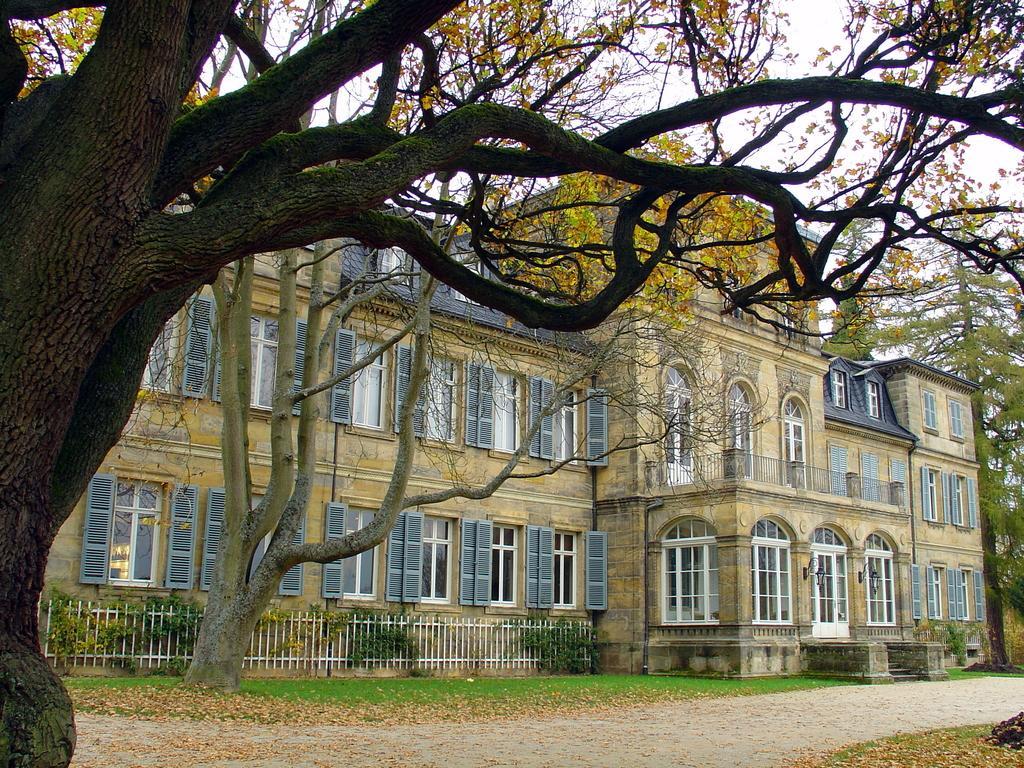Could you give a brief overview of what you see in this image? In this picture we can see the yellow color castle house with white windows and doors. In the front there is a wooden fencing grill and trees. In the front bottom side there is a huge tree. 